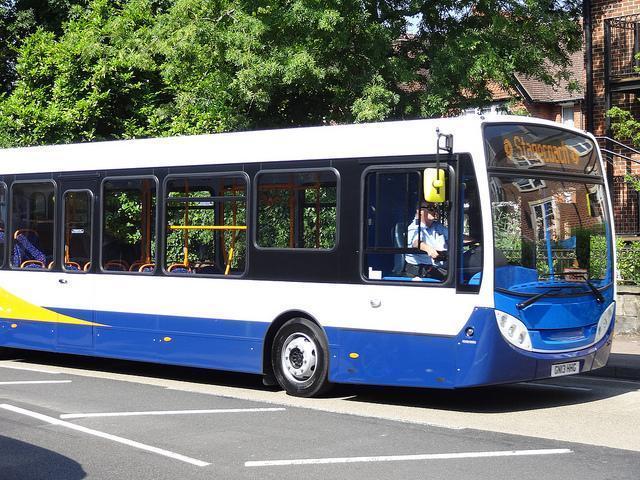Does the image validate the caption "The person is inside the bus."?
Answer yes or no. Yes. Does the image validate the caption "The person is on the bus."?
Answer yes or no. Yes. 